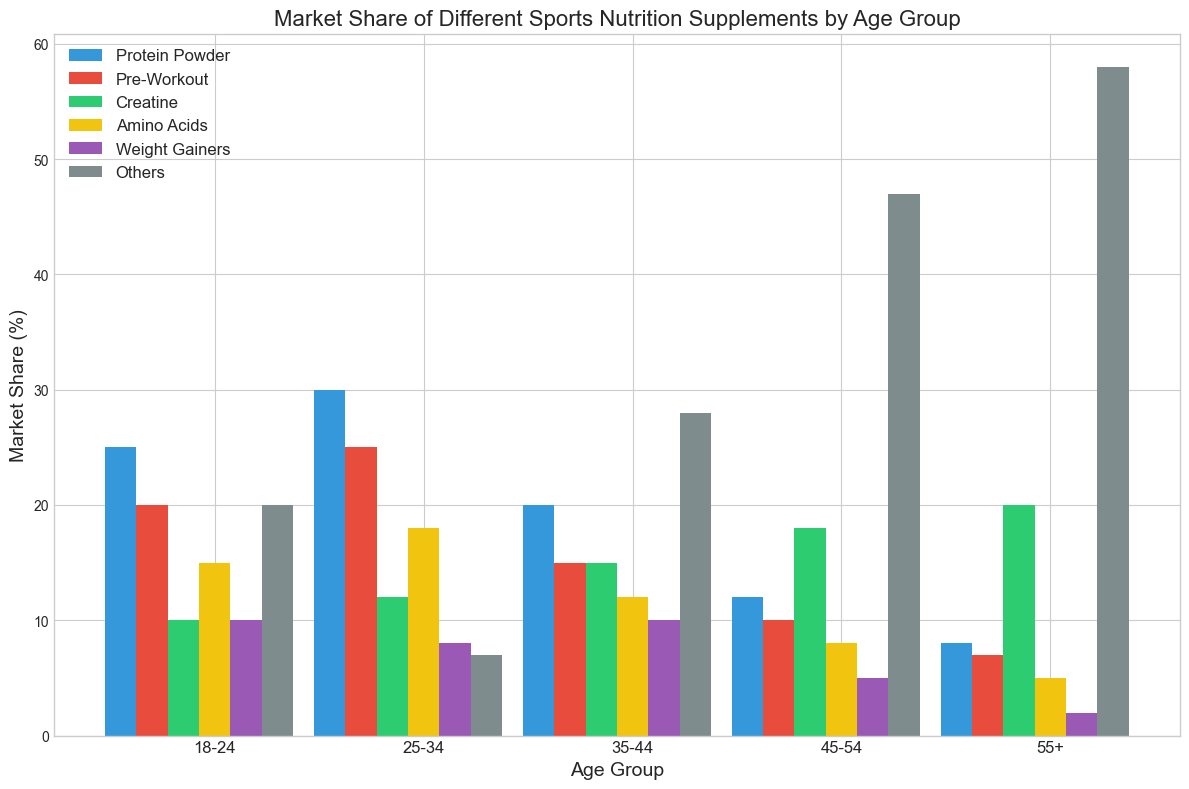What is the market share difference for Creatine between the 35-44 and 45-54 age groups? To find the difference, look at the bar heights of Creatine for the 35-44 and 45-54 age groups on the plot. Subtract the percentage for the 45-54 group (18%) from the 35-44 group percentage (15%)
Answer: -3% Which age group has the highest market share for Pre-Workout supplements? Identify the tallest bar for Pre-Workout supplements by comparing the bar heights for all age groups. The 25-34 age group has the highest bar at 25%
Answer: 25-34 How does the market share of Protein Powder change from the 18-24 to the 55+ age group? Note the bars for Protein Powder from the youngest to the oldest age group: 18-24 (25%), 25-34 (30%), 35-44 (20%), 45-54 (12%), 55+ (8%). The market share decreases as the age increases
Answer: It decreases Which age group shows the lowest market share for Amino Acids? Find the shortest bar for Amino Acids across all age groups. The 55+ age group has the lowest market share at 5%
Answer: 55+ What is the average market share of Weight Gainers across all age groups? First sum the market shares of Weight Gainers for all age groups (10% + 8% + 10% + 5% + 2% = 35%). There are 5 age groups, so divide the total by 5: 35% / 5 = 7%
Answer: 7% Compare the market share of Others supplements between the 18-24 and 55+ age groups Check the bar heights under Others for the 18-24 (20%) and 55+ (58%) age groups. The 55+ age group has a significantly higher market share
Answer: 55+ has higher Calculate the total market share of all supplements for the 45-54 age group Sum the market shares of all categories for the 45-54 age group: 12% + 10% + 18% + 8% + 5% + 47% = 100%
Answer: 100% Which supplement category shows a steady market share as age increases? Compare the bar heights for each supplement category across age groups to find any that maintain a similar height. Amino Acids have relatively small variation across different age groups
Answer: Amino Acids 